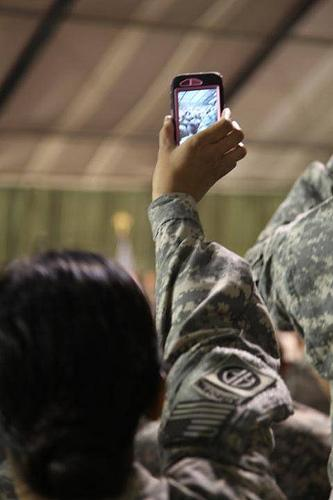Find the specific patch present on the woman's army uniform. There is an American flag patch on the woman's army uniform. What is the color of the wall and ceiling in the image? The wall is green and the ceiling is white. Identify the color of the cell phone case in the image. The cell phone case is pink and black. Examine the cell phone screen and describe what is displayed there. There is an image of several people displayed on the cell phone screen. Count the number of visible cell phones in the image. One cell phone is visible in the image. Provide a brief description of the image, mentioning the main subjects. The image shows a woman wearing an army uniform with an American flag patch, holding a cell phone, and standing near another person in army uniform. How many people are there in the image and how many of them are wearing army uniforms? There are two people in the image, and both of them are wearing army uniforms. Describe the hairstyle of the woman in the image. The woman has dark brown hair wrapped in a bun. What is the primary object being held by the woman? The woman is holding a cell phone with a pink and black case. What kind of garment is the woman wearing? The woman is wearing a military uniform with camouflage fatigues. Do you see a clear Canadian flag in the background instead of a blurry American flag? The image contains a blurry American flag, not a clear Canadian flag. Is the woman holding the cell phone with both hands instead of one hand? No, it's not mentioned in the image. Can you see a large penguin sitting on top of the cell phone? The image contains a cell phone, but there is no mention of a penguin or any other animal in the image. Does the person in the background have blond hair instead of black hair? The person in the background is described as having black hair, not blond hair. 